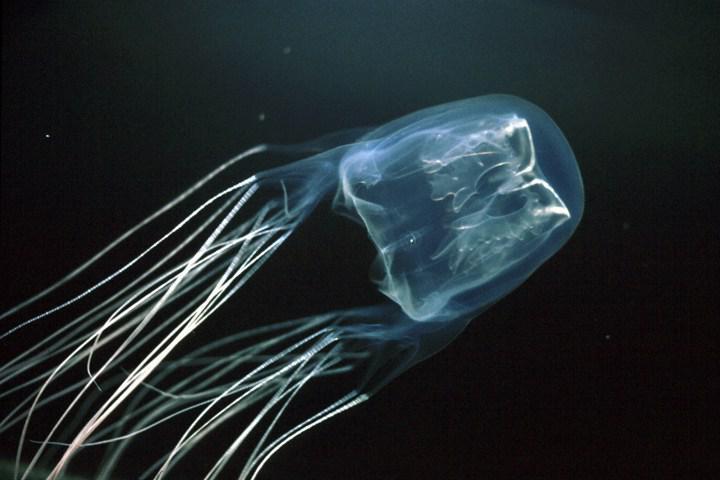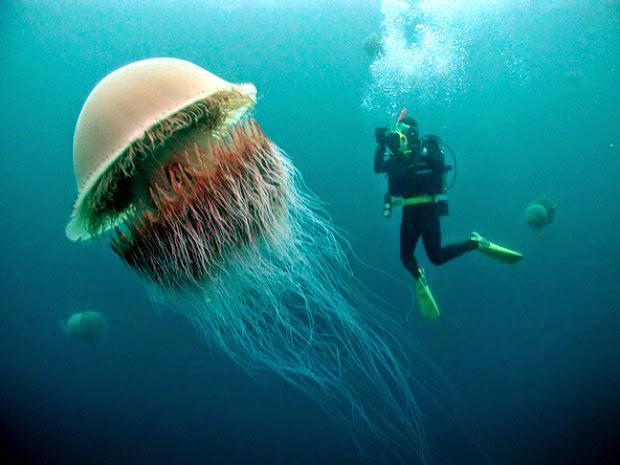The first image is the image on the left, the second image is the image on the right. Considering the images on both sides, is "There is scuba diver in the image on the right." valid? Answer yes or no. Yes. The first image is the image on the left, the second image is the image on the right. Considering the images on both sides, is "Left image includes a diver wearing goggles." valid? Answer yes or no. No. 